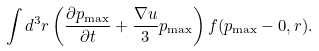Convert formula to latex. <formula><loc_0><loc_0><loc_500><loc_500>\int d ^ { 3 } r \left ( \frac { \partial p _ { \max } } { \partial t } + \frac { \nabla u } { 3 } p _ { \max } \right ) f ( p _ { \max } - 0 , r ) .</formula> 